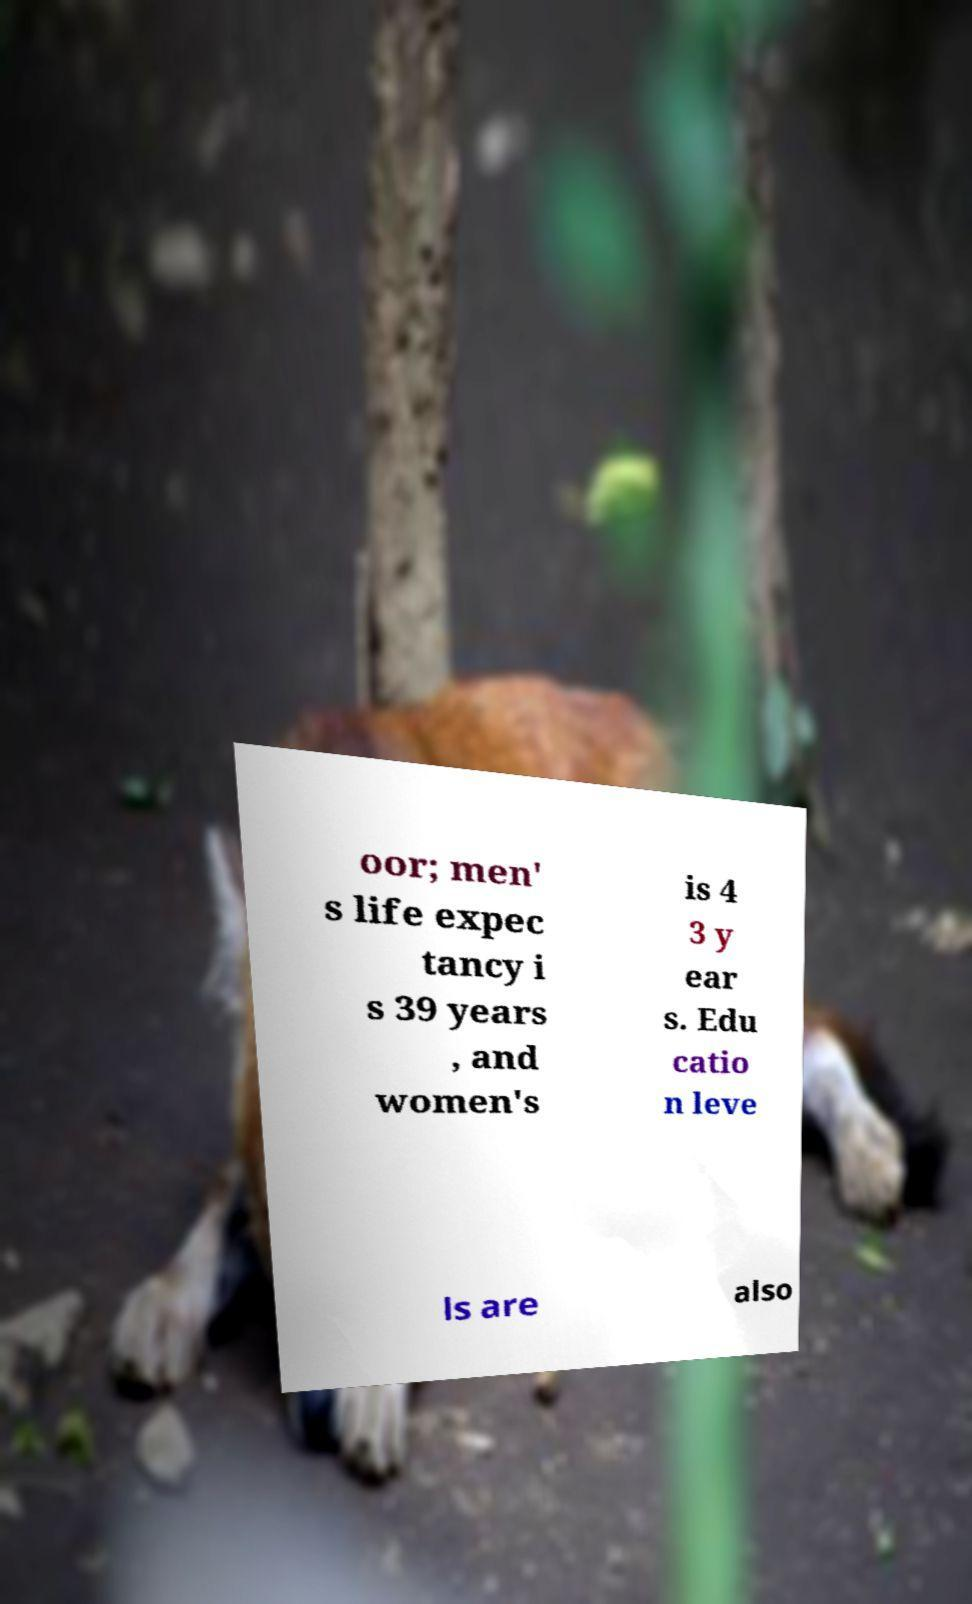For documentation purposes, I need the text within this image transcribed. Could you provide that? oor; men' s life expec tancy i s 39 years , and women's is 4 3 y ear s. Edu catio n leve ls are also 